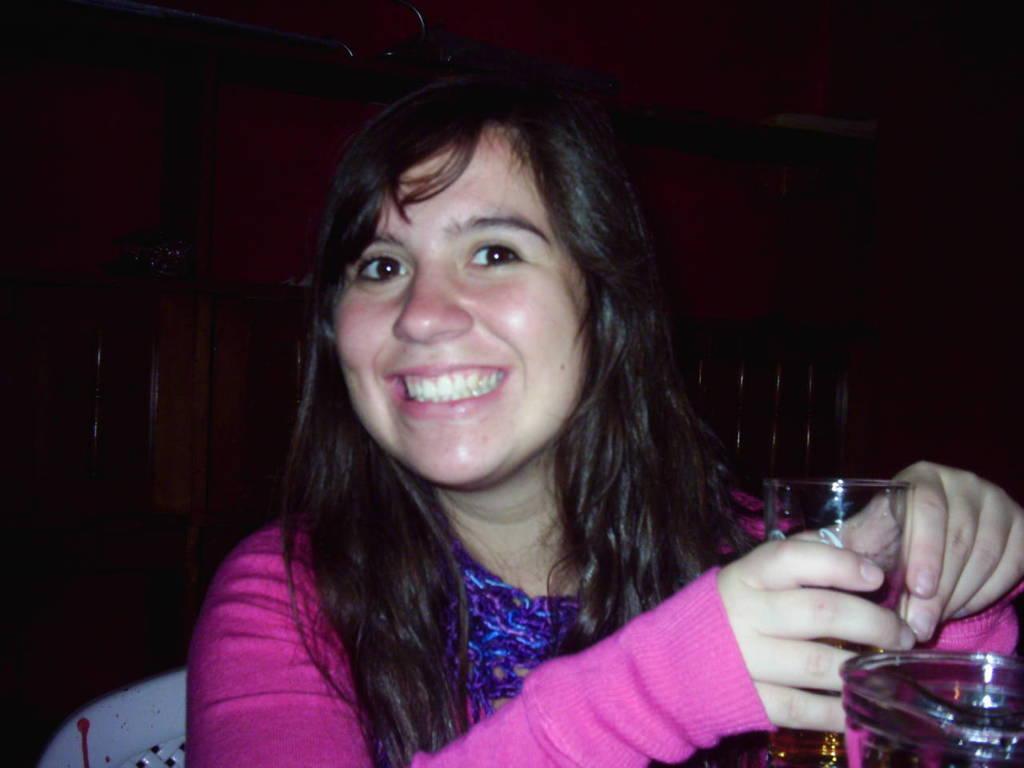Can you describe this image briefly? This image consists of a girl who is sitting in chair. She is wearing pink color sweater. She is smiling. She is holding a glass and there is also on the glass in the bottom right corner. 